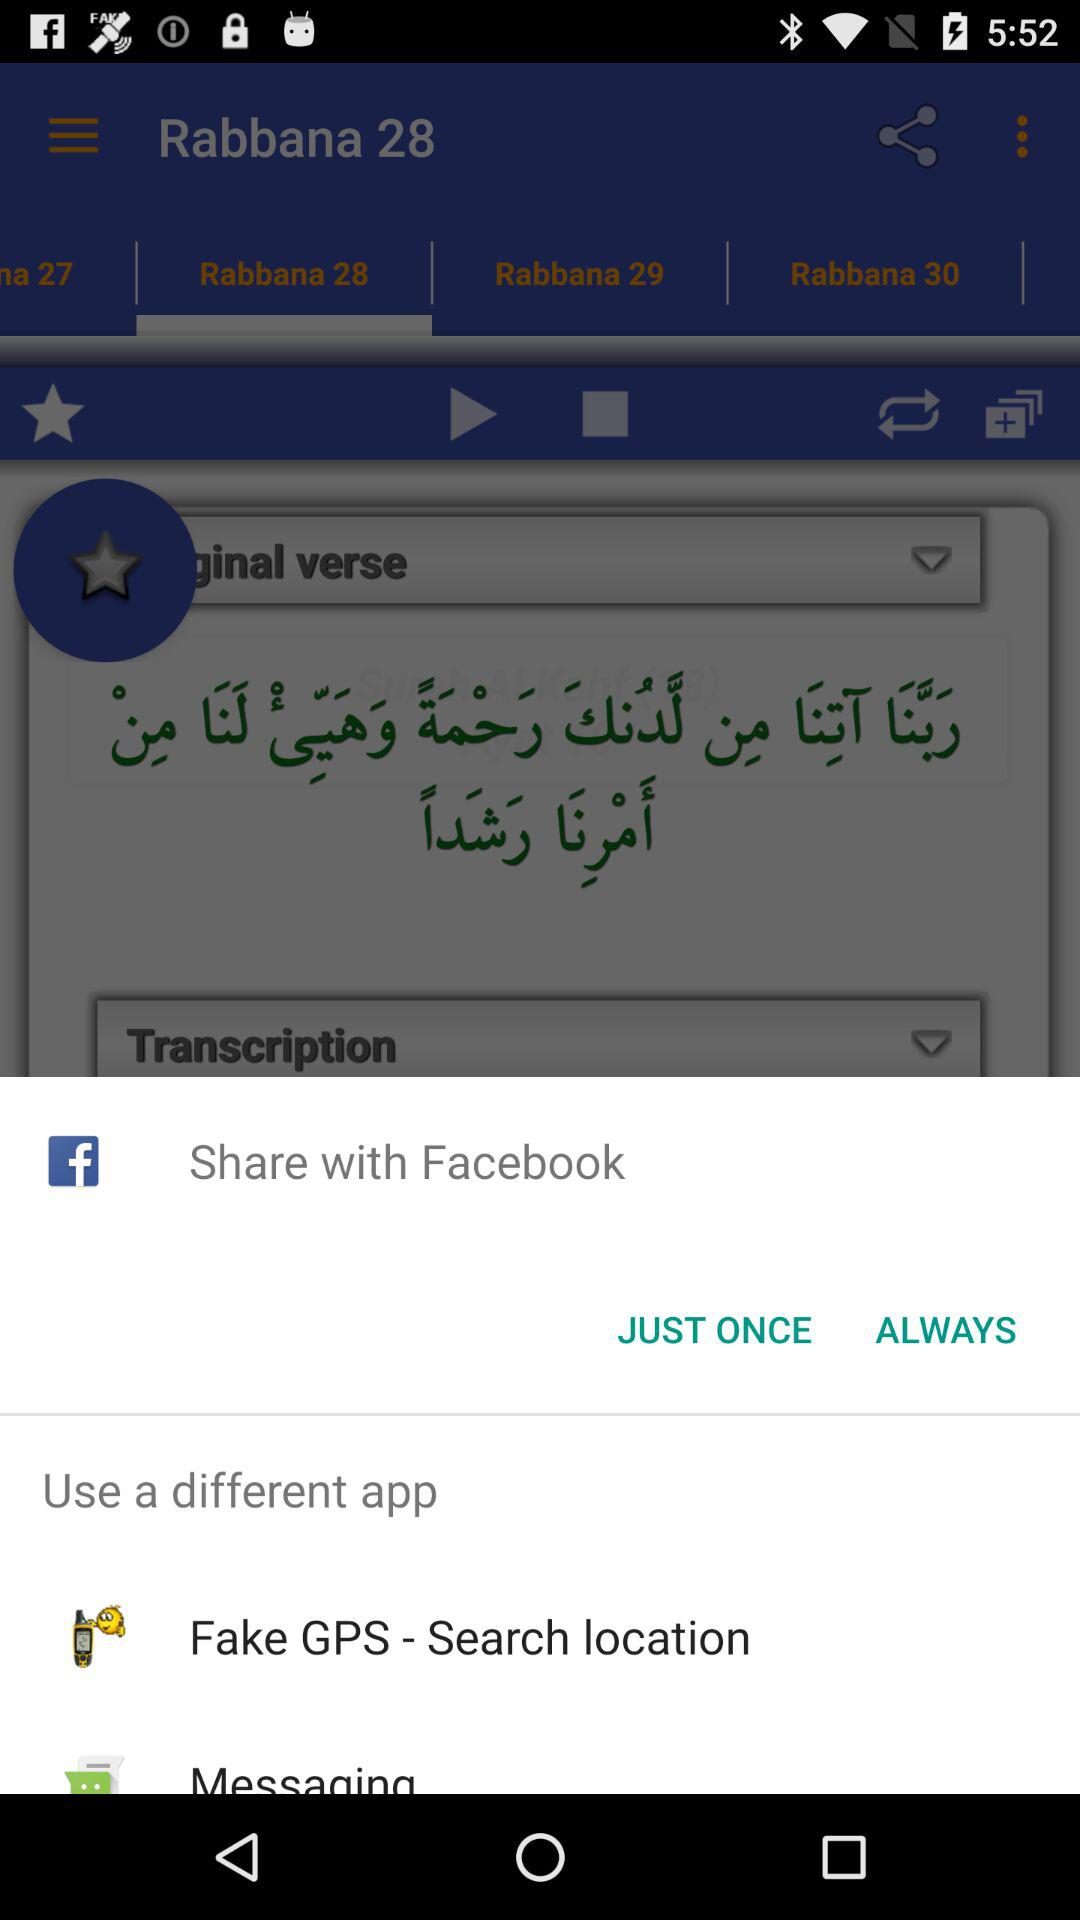Through which application can the content be shared? The content can be shared through "Facebook", "Fake GPS - Search location" and "Messaging". 